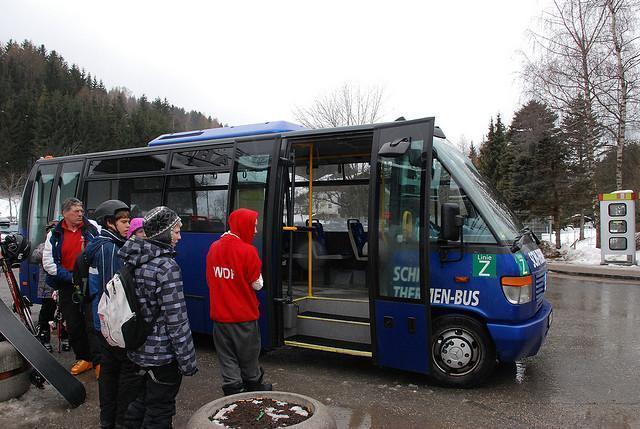Which head covering is made of the hardest material?
Make your selection from the four choices given to correctly answer the question.
Options: Black/white, pink, red, black. Black. 